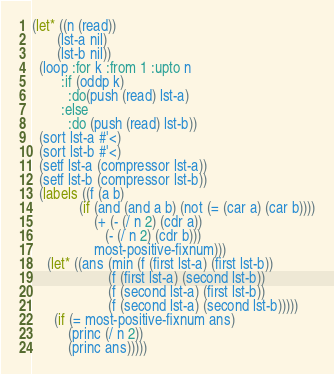<code> <loc_0><loc_0><loc_500><loc_500><_Lisp_>(let* ((n (read))
       (lst-a nil)
       (lst-b nil))
  (loop :for k :from 1 :upto n
        :if (oddp k)
          :do(push (read) lst-a)
        :else
          :do (push (read) lst-b))
  (sort lst-a #'<)
  (sort lst-b #'<)
  (setf lst-a (compressor lst-a))
  (setf lst-b (compressor lst-b))
  (labels ((f (a b)
             (if (and (and a b) (not (= (car a) (car b))))
                 (+ (- (/ n 2) (cdr a))
                    (- (/ n 2) (cdr b)))
                 most-positive-fixnum)))
    (let* ((ans (min (f (first lst-a) (first lst-b))
                     (f (first lst-a) (second lst-b))
                     (f (second lst-a) (first lst-b))
                     (f (second lst-a) (second lst-b)))))
      (if (= most-positive-fixnum ans)
          (princ (/ n 2))
          (princ ans)))))</code> 